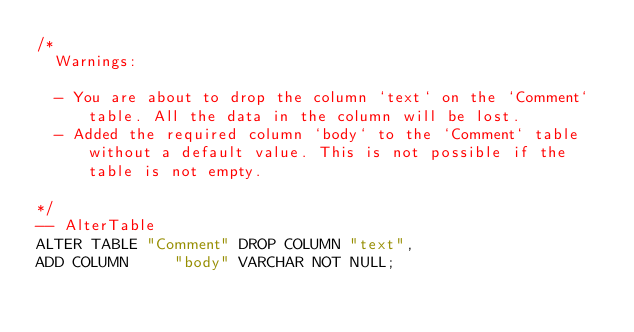<code> <loc_0><loc_0><loc_500><loc_500><_SQL_>/*
  Warnings:

  - You are about to drop the column `text` on the `Comment` table. All the data in the column will be lost.
  - Added the required column `body` to the `Comment` table without a default value. This is not possible if the table is not empty.

*/
-- AlterTable
ALTER TABLE "Comment" DROP COLUMN "text",
ADD COLUMN     "body" VARCHAR NOT NULL;
</code> 